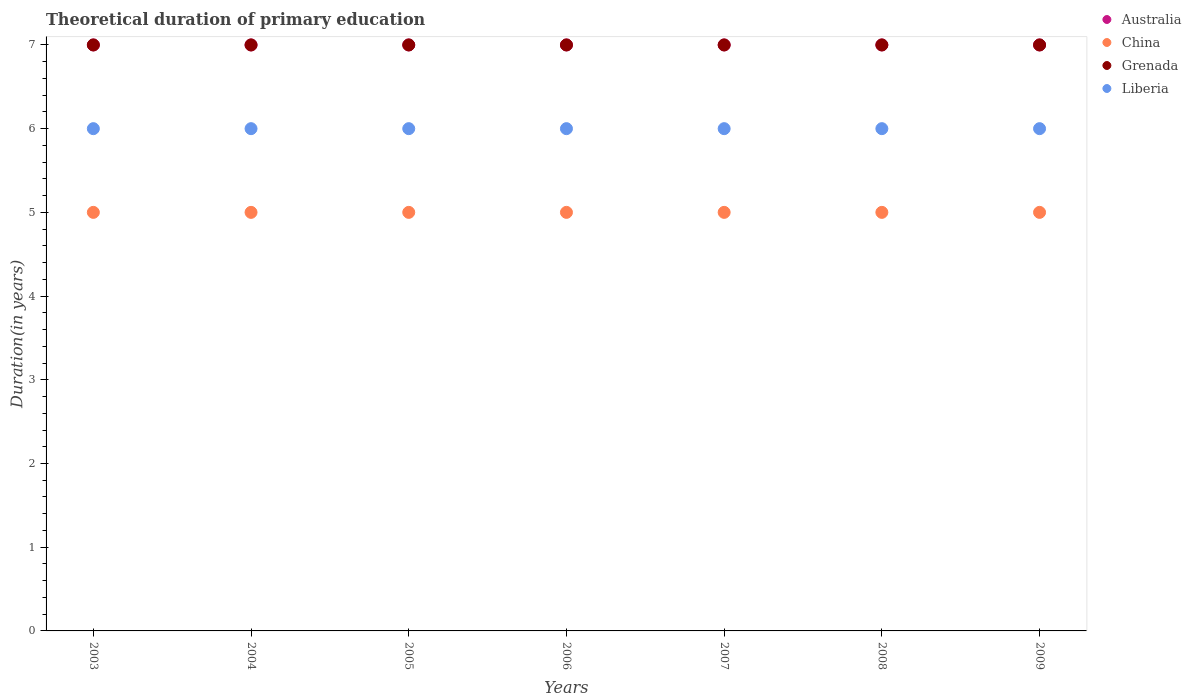Is the number of dotlines equal to the number of legend labels?
Give a very brief answer. Yes. What is the total theoretical duration of primary education in China in 2008?
Keep it short and to the point. 5. Across all years, what is the maximum total theoretical duration of primary education in Australia?
Offer a very short reply. 7. Across all years, what is the minimum total theoretical duration of primary education in Australia?
Provide a succinct answer. 7. What is the total total theoretical duration of primary education in China in the graph?
Offer a very short reply. 35. What is the difference between the total theoretical duration of primary education in China in 2004 and that in 2006?
Provide a succinct answer. 0. What is the difference between the total theoretical duration of primary education in China in 2003 and the total theoretical duration of primary education in Liberia in 2007?
Offer a very short reply. -1. In the year 2008, what is the difference between the total theoretical duration of primary education in China and total theoretical duration of primary education in Liberia?
Ensure brevity in your answer.  -1. In how many years, is the total theoretical duration of primary education in China greater than 6.8 years?
Provide a short and direct response. 0. Is the difference between the total theoretical duration of primary education in China in 2005 and 2007 greater than the difference between the total theoretical duration of primary education in Liberia in 2005 and 2007?
Provide a succinct answer. No. What is the difference between the highest and the lowest total theoretical duration of primary education in Liberia?
Offer a terse response. 0. In how many years, is the total theoretical duration of primary education in Liberia greater than the average total theoretical duration of primary education in Liberia taken over all years?
Keep it short and to the point. 0. Is the sum of the total theoretical duration of primary education in Grenada in 2003 and 2006 greater than the maximum total theoretical duration of primary education in Liberia across all years?
Give a very brief answer. Yes. Is it the case that in every year, the sum of the total theoretical duration of primary education in China and total theoretical duration of primary education in Grenada  is greater than the total theoretical duration of primary education in Liberia?
Your response must be concise. Yes. How many dotlines are there?
Keep it short and to the point. 4. What is the difference between two consecutive major ticks on the Y-axis?
Offer a terse response. 1. Are the values on the major ticks of Y-axis written in scientific E-notation?
Your response must be concise. No. Does the graph contain any zero values?
Your answer should be very brief. No. How many legend labels are there?
Give a very brief answer. 4. How are the legend labels stacked?
Provide a succinct answer. Vertical. What is the title of the graph?
Provide a short and direct response. Theoretical duration of primary education. Does "Vietnam" appear as one of the legend labels in the graph?
Ensure brevity in your answer.  No. What is the label or title of the X-axis?
Offer a very short reply. Years. What is the label or title of the Y-axis?
Offer a very short reply. Duration(in years). What is the Duration(in years) of Australia in 2003?
Keep it short and to the point. 7. What is the Duration(in years) of China in 2003?
Your answer should be compact. 5. What is the Duration(in years) in Liberia in 2003?
Your response must be concise. 6. What is the Duration(in years) in China in 2004?
Give a very brief answer. 5. What is the Duration(in years) of Liberia in 2004?
Your response must be concise. 6. What is the Duration(in years) of Liberia in 2005?
Your answer should be very brief. 6. What is the Duration(in years) in Grenada in 2006?
Make the answer very short. 7. What is the Duration(in years) in Liberia in 2006?
Ensure brevity in your answer.  6. What is the Duration(in years) of Australia in 2007?
Your answer should be compact. 7. What is the Duration(in years) of China in 2007?
Ensure brevity in your answer.  5. What is the Duration(in years) in Australia in 2008?
Give a very brief answer. 7. What is the Duration(in years) in China in 2008?
Offer a terse response. 5. What is the Duration(in years) of Liberia in 2008?
Provide a short and direct response. 6. What is the Duration(in years) in China in 2009?
Your answer should be compact. 5. What is the Duration(in years) of Grenada in 2009?
Your response must be concise. 7. Across all years, what is the maximum Duration(in years) in Australia?
Provide a succinct answer. 7. Across all years, what is the maximum Duration(in years) in Liberia?
Provide a short and direct response. 6. Across all years, what is the minimum Duration(in years) of Liberia?
Your response must be concise. 6. What is the total Duration(in years) in Australia in the graph?
Provide a succinct answer. 49. What is the total Duration(in years) of Liberia in the graph?
Make the answer very short. 42. What is the difference between the Duration(in years) of Australia in 2003 and that in 2004?
Offer a terse response. 0. What is the difference between the Duration(in years) in China in 2003 and that in 2004?
Give a very brief answer. 0. What is the difference between the Duration(in years) of Liberia in 2003 and that in 2005?
Your response must be concise. 0. What is the difference between the Duration(in years) in Australia in 2003 and that in 2006?
Ensure brevity in your answer.  0. What is the difference between the Duration(in years) of China in 2003 and that in 2006?
Make the answer very short. 0. What is the difference between the Duration(in years) in Liberia in 2003 and that in 2006?
Offer a very short reply. 0. What is the difference between the Duration(in years) in China in 2003 and that in 2007?
Provide a short and direct response. 0. What is the difference between the Duration(in years) of Australia in 2003 and that in 2008?
Provide a succinct answer. 0. What is the difference between the Duration(in years) in Liberia in 2003 and that in 2008?
Provide a succinct answer. 0. What is the difference between the Duration(in years) in Australia in 2003 and that in 2009?
Ensure brevity in your answer.  0. What is the difference between the Duration(in years) in Grenada in 2003 and that in 2009?
Offer a very short reply. 0. What is the difference between the Duration(in years) in Australia in 2004 and that in 2005?
Provide a succinct answer. 0. What is the difference between the Duration(in years) of China in 2004 and that in 2005?
Keep it short and to the point. 0. What is the difference between the Duration(in years) in Liberia in 2004 and that in 2005?
Provide a succinct answer. 0. What is the difference between the Duration(in years) in Grenada in 2004 and that in 2006?
Offer a terse response. 0. What is the difference between the Duration(in years) in Australia in 2004 and that in 2007?
Make the answer very short. 0. What is the difference between the Duration(in years) in Grenada in 2004 and that in 2007?
Ensure brevity in your answer.  0. What is the difference between the Duration(in years) of Liberia in 2004 and that in 2007?
Give a very brief answer. 0. What is the difference between the Duration(in years) in Australia in 2004 and that in 2008?
Give a very brief answer. 0. What is the difference between the Duration(in years) of China in 2004 and that in 2008?
Keep it short and to the point. 0. What is the difference between the Duration(in years) of Liberia in 2004 and that in 2008?
Your answer should be very brief. 0. What is the difference between the Duration(in years) of Australia in 2005 and that in 2006?
Your answer should be very brief. 0. What is the difference between the Duration(in years) of China in 2005 and that in 2006?
Give a very brief answer. 0. What is the difference between the Duration(in years) in Liberia in 2005 and that in 2006?
Your response must be concise. 0. What is the difference between the Duration(in years) of China in 2005 and that in 2007?
Make the answer very short. 0. What is the difference between the Duration(in years) of Grenada in 2005 and that in 2007?
Give a very brief answer. 0. What is the difference between the Duration(in years) in Liberia in 2005 and that in 2007?
Your answer should be very brief. 0. What is the difference between the Duration(in years) in China in 2005 and that in 2008?
Your answer should be compact. 0. What is the difference between the Duration(in years) in Liberia in 2005 and that in 2009?
Offer a terse response. 0. What is the difference between the Duration(in years) in China in 2006 and that in 2007?
Make the answer very short. 0. What is the difference between the Duration(in years) of Liberia in 2006 and that in 2007?
Offer a very short reply. 0. What is the difference between the Duration(in years) in Australia in 2006 and that in 2008?
Offer a very short reply. 0. What is the difference between the Duration(in years) in Australia in 2006 and that in 2009?
Offer a very short reply. 0. What is the difference between the Duration(in years) in China in 2006 and that in 2009?
Your answer should be very brief. 0. What is the difference between the Duration(in years) of Australia in 2007 and that in 2008?
Ensure brevity in your answer.  0. What is the difference between the Duration(in years) in Liberia in 2007 and that in 2008?
Provide a succinct answer. 0. What is the difference between the Duration(in years) of Australia in 2007 and that in 2009?
Your response must be concise. 0. What is the difference between the Duration(in years) in China in 2007 and that in 2009?
Your answer should be very brief. 0. What is the difference between the Duration(in years) in Grenada in 2007 and that in 2009?
Give a very brief answer. 0. What is the difference between the Duration(in years) of Liberia in 2007 and that in 2009?
Provide a succinct answer. 0. What is the difference between the Duration(in years) of Australia in 2008 and that in 2009?
Make the answer very short. 0. What is the difference between the Duration(in years) of China in 2008 and that in 2009?
Make the answer very short. 0. What is the difference between the Duration(in years) in Australia in 2003 and the Duration(in years) in China in 2004?
Your answer should be very brief. 2. What is the difference between the Duration(in years) in Australia in 2003 and the Duration(in years) in Liberia in 2004?
Ensure brevity in your answer.  1. What is the difference between the Duration(in years) of China in 2003 and the Duration(in years) of Grenada in 2004?
Your answer should be compact. -2. What is the difference between the Duration(in years) in Australia in 2003 and the Duration(in years) in China in 2005?
Offer a terse response. 2. What is the difference between the Duration(in years) in Australia in 2003 and the Duration(in years) in Grenada in 2005?
Ensure brevity in your answer.  0. What is the difference between the Duration(in years) in Australia in 2003 and the Duration(in years) in Liberia in 2005?
Offer a very short reply. 1. What is the difference between the Duration(in years) in China in 2003 and the Duration(in years) in Grenada in 2005?
Ensure brevity in your answer.  -2. What is the difference between the Duration(in years) in China in 2003 and the Duration(in years) in Liberia in 2005?
Offer a terse response. -1. What is the difference between the Duration(in years) in Grenada in 2003 and the Duration(in years) in Liberia in 2005?
Give a very brief answer. 1. What is the difference between the Duration(in years) of Australia in 2003 and the Duration(in years) of China in 2006?
Your answer should be very brief. 2. What is the difference between the Duration(in years) in Australia in 2003 and the Duration(in years) in Grenada in 2006?
Your answer should be compact. 0. What is the difference between the Duration(in years) of Australia in 2003 and the Duration(in years) of Liberia in 2006?
Make the answer very short. 1. What is the difference between the Duration(in years) of China in 2003 and the Duration(in years) of Liberia in 2006?
Keep it short and to the point. -1. What is the difference between the Duration(in years) in Grenada in 2003 and the Duration(in years) in Liberia in 2006?
Provide a short and direct response. 1. What is the difference between the Duration(in years) in Australia in 2003 and the Duration(in years) in Grenada in 2007?
Offer a very short reply. 0. What is the difference between the Duration(in years) of Australia in 2003 and the Duration(in years) of Liberia in 2007?
Give a very brief answer. 1. What is the difference between the Duration(in years) in Australia in 2003 and the Duration(in years) in China in 2008?
Make the answer very short. 2. What is the difference between the Duration(in years) of Australia in 2003 and the Duration(in years) of Grenada in 2008?
Keep it short and to the point. 0. What is the difference between the Duration(in years) of Australia in 2003 and the Duration(in years) of Liberia in 2008?
Keep it short and to the point. 1. What is the difference between the Duration(in years) of China in 2003 and the Duration(in years) of Liberia in 2008?
Make the answer very short. -1. What is the difference between the Duration(in years) in Grenada in 2003 and the Duration(in years) in Liberia in 2008?
Offer a very short reply. 1. What is the difference between the Duration(in years) in China in 2003 and the Duration(in years) in Grenada in 2009?
Your response must be concise. -2. What is the difference between the Duration(in years) of Grenada in 2003 and the Duration(in years) of Liberia in 2009?
Offer a very short reply. 1. What is the difference between the Duration(in years) in Australia in 2004 and the Duration(in years) in Grenada in 2005?
Make the answer very short. 0. What is the difference between the Duration(in years) of Grenada in 2004 and the Duration(in years) of Liberia in 2005?
Ensure brevity in your answer.  1. What is the difference between the Duration(in years) in Australia in 2004 and the Duration(in years) in Liberia in 2006?
Offer a very short reply. 1. What is the difference between the Duration(in years) in China in 2004 and the Duration(in years) in Grenada in 2006?
Your response must be concise. -2. What is the difference between the Duration(in years) in Grenada in 2004 and the Duration(in years) in Liberia in 2006?
Your response must be concise. 1. What is the difference between the Duration(in years) in Australia in 2004 and the Duration(in years) in China in 2007?
Your answer should be very brief. 2. What is the difference between the Duration(in years) in Australia in 2004 and the Duration(in years) in Grenada in 2007?
Offer a terse response. 0. What is the difference between the Duration(in years) in Australia in 2004 and the Duration(in years) in Liberia in 2007?
Make the answer very short. 1. What is the difference between the Duration(in years) of China in 2004 and the Duration(in years) of Grenada in 2007?
Provide a succinct answer. -2. What is the difference between the Duration(in years) of China in 2004 and the Duration(in years) of Liberia in 2007?
Provide a short and direct response. -1. What is the difference between the Duration(in years) of Grenada in 2004 and the Duration(in years) of Liberia in 2007?
Your answer should be compact. 1. What is the difference between the Duration(in years) of Australia in 2004 and the Duration(in years) of China in 2008?
Offer a very short reply. 2. What is the difference between the Duration(in years) in Australia in 2004 and the Duration(in years) in Liberia in 2008?
Your answer should be compact. 1. What is the difference between the Duration(in years) in China in 2004 and the Duration(in years) in Grenada in 2008?
Provide a short and direct response. -2. What is the difference between the Duration(in years) of China in 2004 and the Duration(in years) of Liberia in 2008?
Provide a succinct answer. -1. What is the difference between the Duration(in years) in Australia in 2004 and the Duration(in years) in China in 2009?
Your response must be concise. 2. What is the difference between the Duration(in years) of Australia in 2004 and the Duration(in years) of Grenada in 2009?
Provide a succinct answer. 0. What is the difference between the Duration(in years) in China in 2004 and the Duration(in years) in Grenada in 2009?
Give a very brief answer. -2. What is the difference between the Duration(in years) of China in 2004 and the Duration(in years) of Liberia in 2009?
Ensure brevity in your answer.  -1. What is the difference between the Duration(in years) in Grenada in 2004 and the Duration(in years) in Liberia in 2009?
Keep it short and to the point. 1. What is the difference between the Duration(in years) in Australia in 2005 and the Duration(in years) in China in 2006?
Keep it short and to the point. 2. What is the difference between the Duration(in years) in Australia in 2005 and the Duration(in years) in Grenada in 2006?
Your answer should be very brief. 0. What is the difference between the Duration(in years) of China in 2005 and the Duration(in years) of Liberia in 2006?
Your response must be concise. -1. What is the difference between the Duration(in years) in Grenada in 2005 and the Duration(in years) in Liberia in 2006?
Keep it short and to the point. 1. What is the difference between the Duration(in years) in Australia in 2005 and the Duration(in years) in Liberia in 2007?
Provide a succinct answer. 1. What is the difference between the Duration(in years) in Grenada in 2005 and the Duration(in years) in Liberia in 2007?
Offer a terse response. 1. What is the difference between the Duration(in years) in Australia in 2005 and the Duration(in years) in China in 2008?
Your answer should be very brief. 2. What is the difference between the Duration(in years) of Grenada in 2005 and the Duration(in years) of Liberia in 2008?
Provide a short and direct response. 1. What is the difference between the Duration(in years) in Australia in 2005 and the Duration(in years) in China in 2009?
Your answer should be very brief. 2. What is the difference between the Duration(in years) in China in 2005 and the Duration(in years) in Grenada in 2009?
Your answer should be compact. -2. What is the difference between the Duration(in years) in Australia in 2006 and the Duration(in years) in Grenada in 2007?
Make the answer very short. 0. What is the difference between the Duration(in years) in China in 2006 and the Duration(in years) in Grenada in 2007?
Your response must be concise. -2. What is the difference between the Duration(in years) in China in 2006 and the Duration(in years) in Liberia in 2007?
Offer a terse response. -1. What is the difference between the Duration(in years) of Australia in 2006 and the Duration(in years) of China in 2008?
Provide a succinct answer. 2. What is the difference between the Duration(in years) of Grenada in 2006 and the Duration(in years) of Liberia in 2009?
Give a very brief answer. 1. What is the difference between the Duration(in years) in Australia in 2007 and the Duration(in years) in China in 2008?
Your response must be concise. 2. What is the difference between the Duration(in years) in China in 2007 and the Duration(in years) in Grenada in 2008?
Make the answer very short. -2. What is the difference between the Duration(in years) in China in 2007 and the Duration(in years) in Liberia in 2008?
Your answer should be compact. -1. What is the difference between the Duration(in years) of Grenada in 2007 and the Duration(in years) of Liberia in 2008?
Offer a very short reply. 1. What is the difference between the Duration(in years) of Australia in 2007 and the Duration(in years) of China in 2009?
Provide a succinct answer. 2. What is the difference between the Duration(in years) of Australia in 2007 and the Duration(in years) of Grenada in 2009?
Provide a short and direct response. 0. What is the difference between the Duration(in years) in China in 2007 and the Duration(in years) in Grenada in 2009?
Provide a short and direct response. -2. What is the difference between the Duration(in years) in Grenada in 2007 and the Duration(in years) in Liberia in 2009?
Provide a short and direct response. 1. What is the difference between the Duration(in years) in Australia in 2008 and the Duration(in years) in Grenada in 2009?
Ensure brevity in your answer.  0. What is the difference between the Duration(in years) of China in 2008 and the Duration(in years) of Liberia in 2009?
Keep it short and to the point. -1. What is the average Duration(in years) of China per year?
Provide a succinct answer. 5. What is the average Duration(in years) in Grenada per year?
Offer a very short reply. 7. What is the average Duration(in years) of Liberia per year?
Provide a short and direct response. 6. In the year 2003, what is the difference between the Duration(in years) of Australia and Duration(in years) of China?
Your answer should be compact. 2. In the year 2003, what is the difference between the Duration(in years) of Australia and Duration(in years) of Grenada?
Offer a very short reply. 0. In the year 2003, what is the difference between the Duration(in years) of China and Duration(in years) of Grenada?
Your answer should be very brief. -2. In the year 2003, what is the difference between the Duration(in years) in Grenada and Duration(in years) in Liberia?
Your answer should be compact. 1. In the year 2004, what is the difference between the Duration(in years) in Australia and Duration(in years) in Grenada?
Provide a short and direct response. 0. In the year 2004, what is the difference between the Duration(in years) in China and Duration(in years) in Grenada?
Offer a very short reply. -2. In the year 2004, what is the difference between the Duration(in years) of China and Duration(in years) of Liberia?
Your answer should be compact. -1. In the year 2005, what is the difference between the Duration(in years) in Australia and Duration(in years) in China?
Your response must be concise. 2. In the year 2005, what is the difference between the Duration(in years) of China and Duration(in years) of Grenada?
Your response must be concise. -2. In the year 2005, what is the difference between the Duration(in years) in Grenada and Duration(in years) in Liberia?
Make the answer very short. 1. In the year 2006, what is the difference between the Duration(in years) in Australia and Duration(in years) in China?
Give a very brief answer. 2. In the year 2006, what is the difference between the Duration(in years) in China and Duration(in years) in Grenada?
Make the answer very short. -2. In the year 2006, what is the difference between the Duration(in years) in China and Duration(in years) in Liberia?
Your answer should be very brief. -1. In the year 2008, what is the difference between the Duration(in years) in Australia and Duration(in years) in Grenada?
Give a very brief answer. 0. In the year 2008, what is the difference between the Duration(in years) of Australia and Duration(in years) of Liberia?
Your response must be concise. 1. In the year 2009, what is the difference between the Duration(in years) in Australia and Duration(in years) in Grenada?
Provide a short and direct response. 0. What is the ratio of the Duration(in years) of Australia in 2003 to that in 2004?
Provide a succinct answer. 1. What is the ratio of the Duration(in years) of Grenada in 2003 to that in 2004?
Your answer should be compact. 1. What is the ratio of the Duration(in years) of Australia in 2003 to that in 2006?
Provide a short and direct response. 1. What is the ratio of the Duration(in years) in Grenada in 2003 to that in 2006?
Your answer should be compact. 1. What is the ratio of the Duration(in years) of Liberia in 2003 to that in 2006?
Your answer should be very brief. 1. What is the ratio of the Duration(in years) in China in 2003 to that in 2008?
Offer a terse response. 1. What is the ratio of the Duration(in years) in Australia in 2003 to that in 2009?
Offer a very short reply. 1. What is the ratio of the Duration(in years) of China in 2003 to that in 2009?
Your answer should be very brief. 1. What is the ratio of the Duration(in years) of Grenada in 2003 to that in 2009?
Offer a terse response. 1. What is the ratio of the Duration(in years) in China in 2004 to that in 2005?
Your response must be concise. 1. What is the ratio of the Duration(in years) of Liberia in 2004 to that in 2005?
Offer a terse response. 1. What is the ratio of the Duration(in years) in Australia in 2004 to that in 2006?
Make the answer very short. 1. What is the ratio of the Duration(in years) of Grenada in 2004 to that in 2006?
Keep it short and to the point. 1. What is the ratio of the Duration(in years) of Liberia in 2004 to that in 2006?
Your answer should be very brief. 1. What is the ratio of the Duration(in years) in Australia in 2004 to that in 2007?
Your response must be concise. 1. What is the ratio of the Duration(in years) of Liberia in 2004 to that in 2007?
Provide a succinct answer. 1. What is the ratio of the Duration(in years) of China in 2004 to that in 2008?
Offer a terse response. 1. What is the ratio of the Duration(in years) in Liberia in 2004 to that in 2008?
Provide a succinct answer. 1. What is the ratio of the Duration(in years) in China in 2004 to that in 2009?
Offer a very short reply. 1. What is the ratio of the Duration(in years) of Grenada in 2004 to that in 2009?
Your answer should be compact. 1. What is the ratio of the Duration(in years) of Liberia in 2004 to that in 2009?
Provide a succinct answer. 1. What is the ratio of the Duration(in years) in China in 2005 to that in 2006?
Make the answer very short. 1. What is the ratio of the Duration(in years) in Liberia in 2005 to that in 2006?
Your answer should be very brief. 1. What is the ratio of the Duration(in years) in Australia in 2005 to that in 2007?
Ensure brevity in your answer.  1. What is the ratio of the Duration(in years) of Grenada in 2005 to that in 2007?
Offer a terse response. 1. What is the ratio of the Duration(in years) of Liberia in 2005 to that in 2007?
Make the answer very short. 1. What is the ratio of the Duration(in years) in Australia in 2005 to that in 2008?
Offer a very short reply. 1. What is the ratio of the Duration(in years) of Grenada in 2005 to that in 2008?
Keep it short and to the point. 1. What is the ratio of the Duration(in years) in Liberia in 2005 to that in 2008?
Provide a succinct answer. 1. What is the ratio of the Duration(in years) in China in 2005 to that in 2009?
Provide a succinct answer. 1. What is the ratio of the Duration(in years) of Grenada in 2005 to that in 2009?
Your answer should be very brief. 1. What is the ratio of the Duration(in years) in Liberia in 2005 to that in 2009?
Keep it short and to the point. 1. What is the ratio of the Duration(in years) in Australia in 2006 to that in 2007?
Give a very brief answer. 1. What is the ratio of the Duration(in years) of China in 2006 to that in 2007?
Your answer should be compact. 1. What is the ratio of the Duration(in years) in Australia in 2006 to that in 2009?
Your answer should be very brief. 1. What is the ratio of the Duration(in years) in China in 2006 to that in 2009?
Your answer should be very brief. 1. What is the ratio of the Duration(in years) of Australia in 2007 to that in 2008?
Offer a very short reply. 1. What is the ratio of the Duration(in years) of China in 2007 to that in 2008?
Give a very brief answer. 1. What is the ratio of the Duration(in years) of Grenada in 2007 to that in 2008?
Your response must be concise. 1. What is the ratio of the Duration(in years) of Liberia in 2007 to that in 2008?
Ensure brevity in your answer.  1. What is the ratio of the Duration(in years) of Australia in 2007 to that in 2009?
Provide a short and direct response. 1. What is the ratio of the Duration(in years) in Grenada in 2007 to that in 2009?
Your answer should be compact. 1. What is the ratio of the Duration(in years) in Liberia in 2007 to that in 2009?
Your answer should be very brief. 1. What is the ratio of the Duration(in years) of China in 2008 to that in 2009?
Keep it short and to the point. 1. What is the ratio of the Duration(in years) of Grenada in 2008 to that in 2009?
Your answer should be compact. 1. What is the difference between the highest and the second highest Duration(in years) in Australia?
Your response must be concise. 0. What is the difference between the highest and the second highest Duration(in years) in China?
Make the answer very short. 0. What is the difference between the highest and the second highest Duration(in years) of Grenada?
Make the answer very short. 0. What is the difference between the highest and the lowest Duration(in years) of China?
Offer a very short reply. 0. What is the difference between the highest and the lowest Duration(in years) of Grenada?
Ensure brevity in your answer.  0. What is the difference between the highest and the lowest Duration(in years) in Liberia?
Provide a succinct answer. 0. 